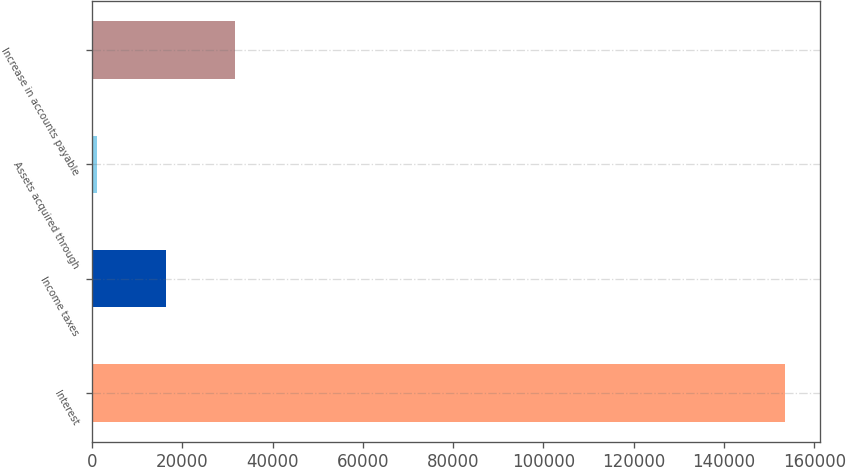Convert chart. <chart><loc_0><loc_0><loc_500><loc_500><bar_chart><fcel>Interest<fcel>Income taxes<fcel>Assets acquired through<fcel>Increase in accounts payable<nl><fcel>153607<fcel>16377.7<fcel>1130<fcel>31625.4<nl></chart> 